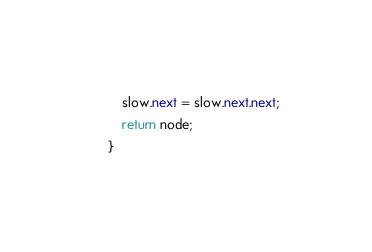<code> <loc_0><loc_0><loc_500><loc_500><_Java_>        slow.next = slow.next.next;
        return node;
    }

</code> 